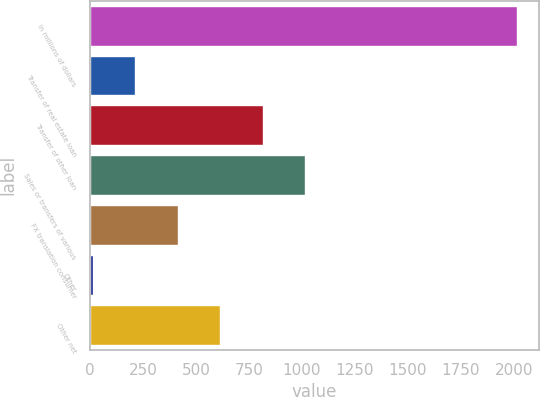<chart> <loc_0><loc_0><loc_500><loc_500><bar_chart><fcel>In millions of dollars<fcel>Transfer of real estate loan<fcel>Transfer of other loan<fcel>Sales or transfers of various<fcel>FX translation consumer<fcel>Other<fcel>Other net<nl><fcel>2017<fcel>214.3<fcel>815.2<fcel>1015.5<fcel>414.6<fcel>14<fcel>614.9<nl></chart> 